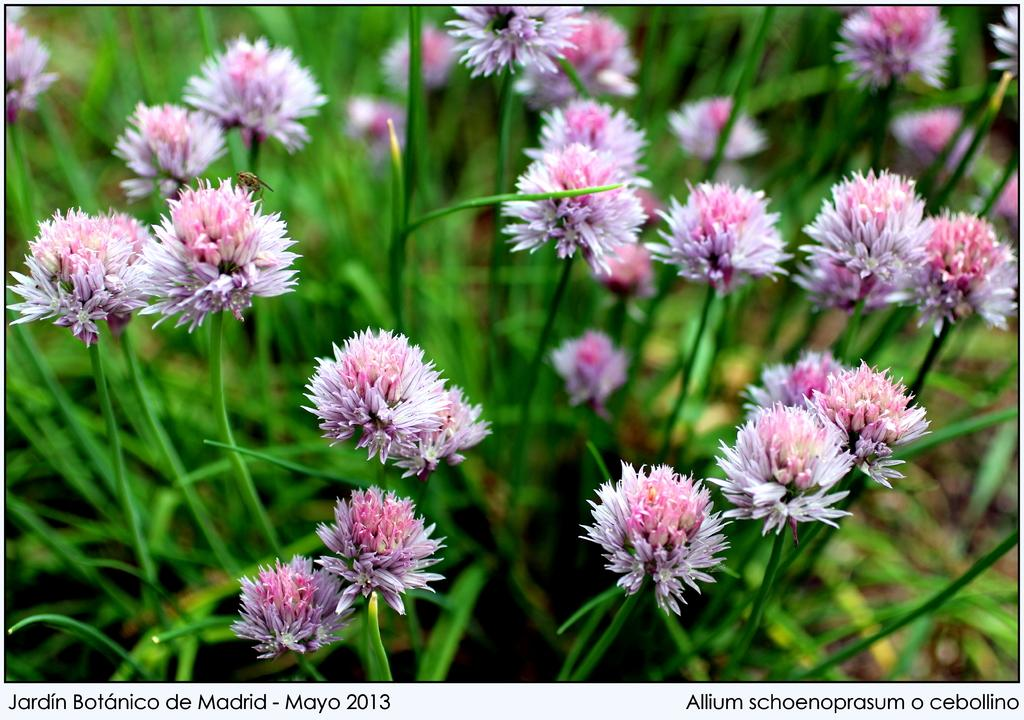What type of living organisms can be seen in the image? Plants can be seen in the image. What additional features can be observed on the plants? The plants have flowers. What way do the plants express their feelings in the image? Plants do not have feelings or express them, so this question cannot be answered based on the image. 